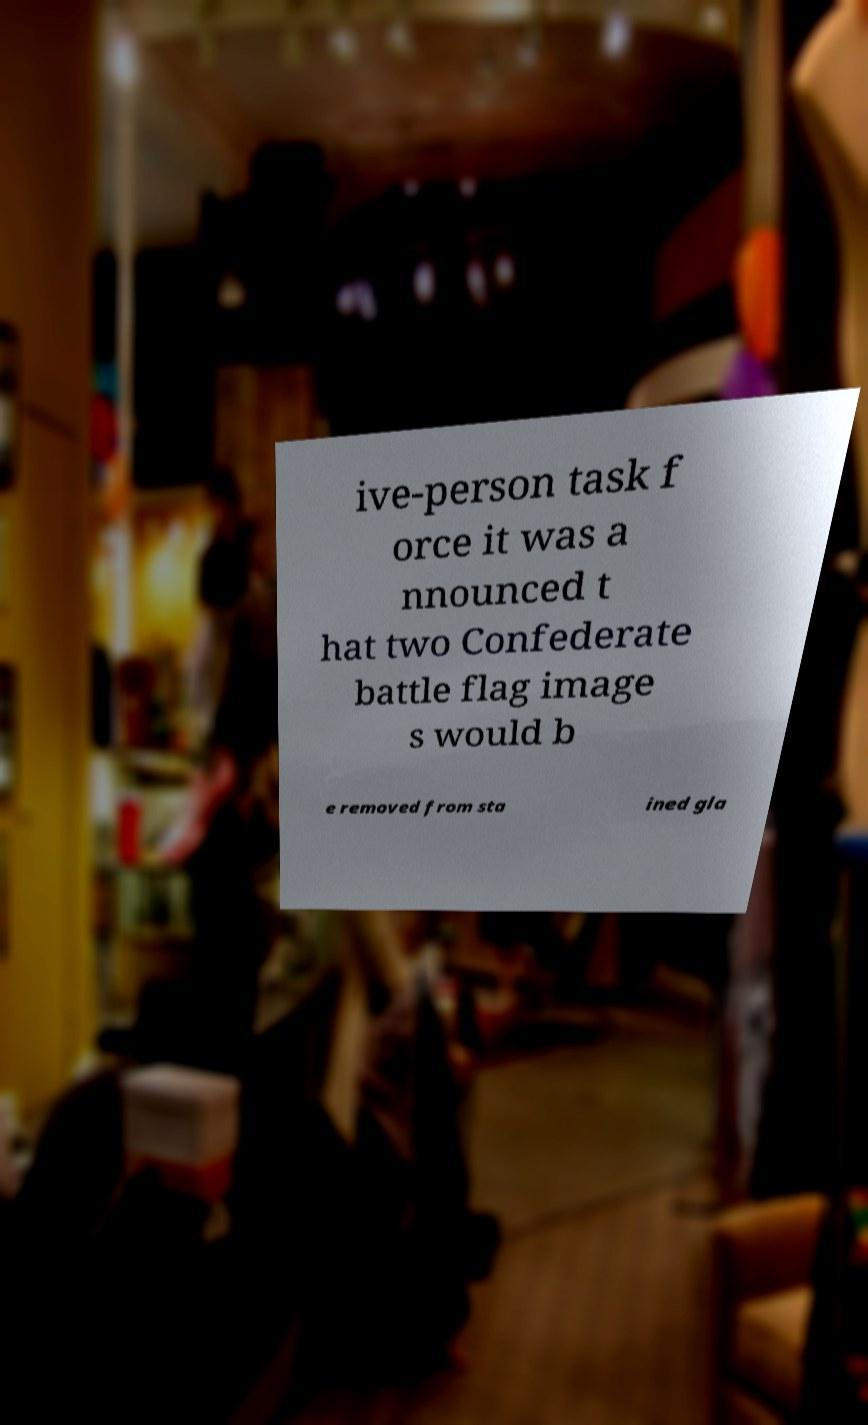Can you accurately transcribe the text from the provided image for me? ive-person task f orce it was a nnounced t hat two Confederate battle flag image s would b e removed from sta ined gla 